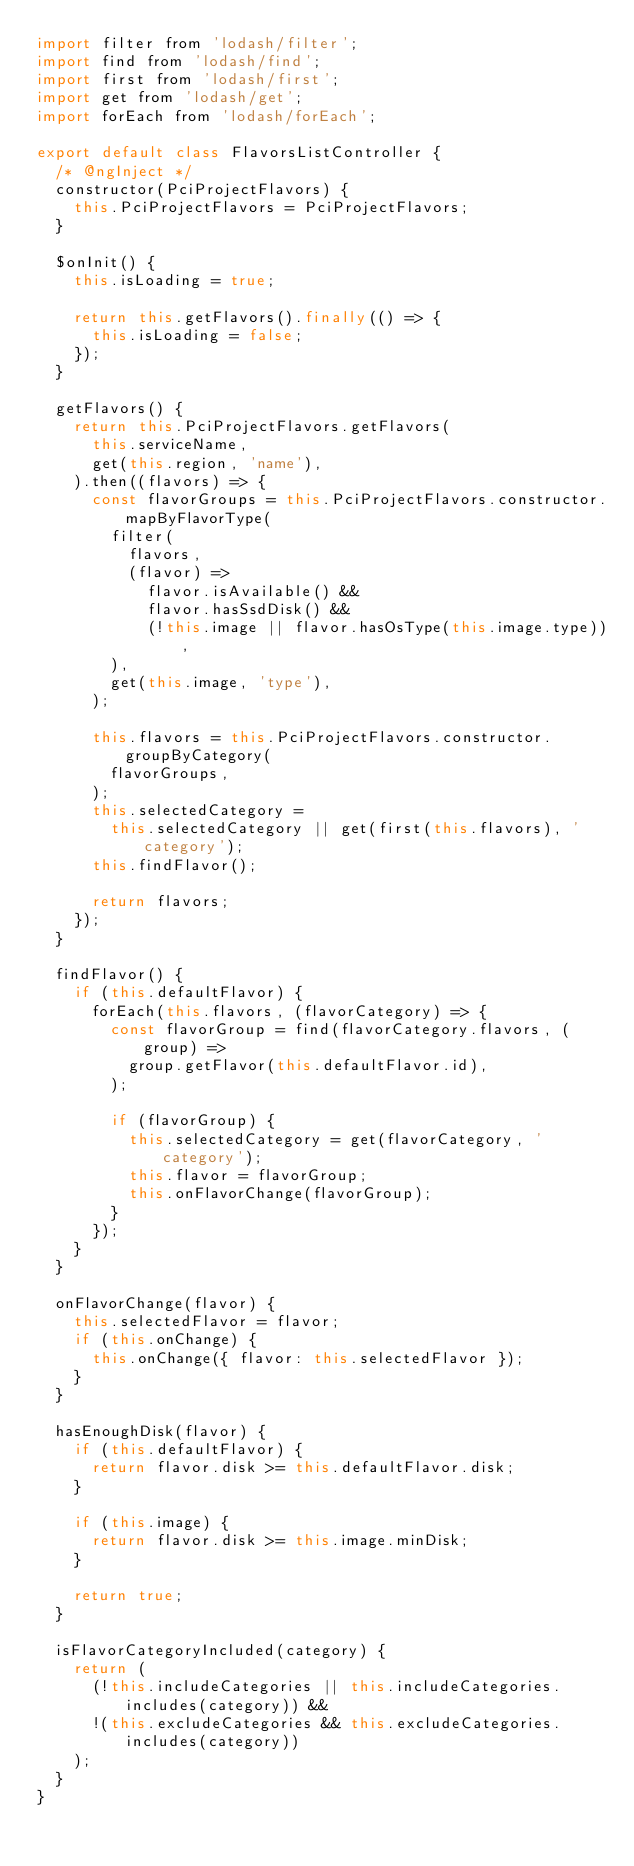Convert code to text. <code><loc_0><loc_0><loc_500><loc_500><_JavaScript_>import filter from 'lodash/filter';
import find from 'lodash/find';
import first from 'lodash/first';
import get from 'lodash/get';
import forEach from 'lodash/forEach';

export default class FlavorsListController {
  /* @ngInject */
  constructor(PciProjectFlavors) {
    this.PciProjectFlavors = PciProjectFlavors;
  }

  $onInit() {
    this.isLoading = true;

    return this.getFlavors().finally(() => {
      this.isLoading = false;
    });
  }

  getFlavors() {
    return this.PciProjectFlavors.getFlavors(
      this.serviceName,
      get(this.region, 'name'),
    ).then((flavors) => {
      const flavorGroups = this.PciProjectFlavors.constructor.mapByFlavorType(
        filter(
          flavors,
          (flavor) =>
            flavor.isAvailable() &&
            flavor.hasSsdDisk() &&
            (!this.image || flavor.hasOsType(this.image.type)),
        ),
        get(this.image, 'type'),
      );

      this.flavors = this.PciProjectFlavors.constructor.groupByCategory(
        flavorGroups,
      );
      this.selectedCategory =
        this.selectedCategory || get(first(this.flavors), 'category');
      this.findFlavor();

      return flavors;
    });
  }

  findFlavor() {
    if (this.defaultFlavor) {
      forEach(this.flavors, (flavorCategory) => {
        const flavorGroup = find(flavorCategory.flavors, (group) =>
          group.getFlavor(this.defaultFlavor.id),
        );

        if (flavorGroup) {
          this.selectedCategory = get(flavorCategory, 'category');
          this.flavor = flavorGroup;
          this.onFlavorChange(flavorGroup);
        }
      });
    }
  }

  onFlavorChange(flavor) {
    this.selectedFlavor = flavor;
    if (this.onChange) {
      this.onChange({ flavor: this.selectedFlavor });
    }
  }

  hasEnoughDisk(flavor) {
    if (this.defaultFlavor) {
      return flavor.disk >= this.defaultFlavor.disk;
    }

    if (this.image) {
      return flavor.disk >= this.image.minDisk;
    }

    return true;
  }

  isFlavorCategoryIncluded(category) {
    return (
      (!this.includeCategories || this.includeCategories.includes(category)) &&
      !(this.excludeCategories && this.excludeCategories.includes(category))
    );
  }
}
</code> 